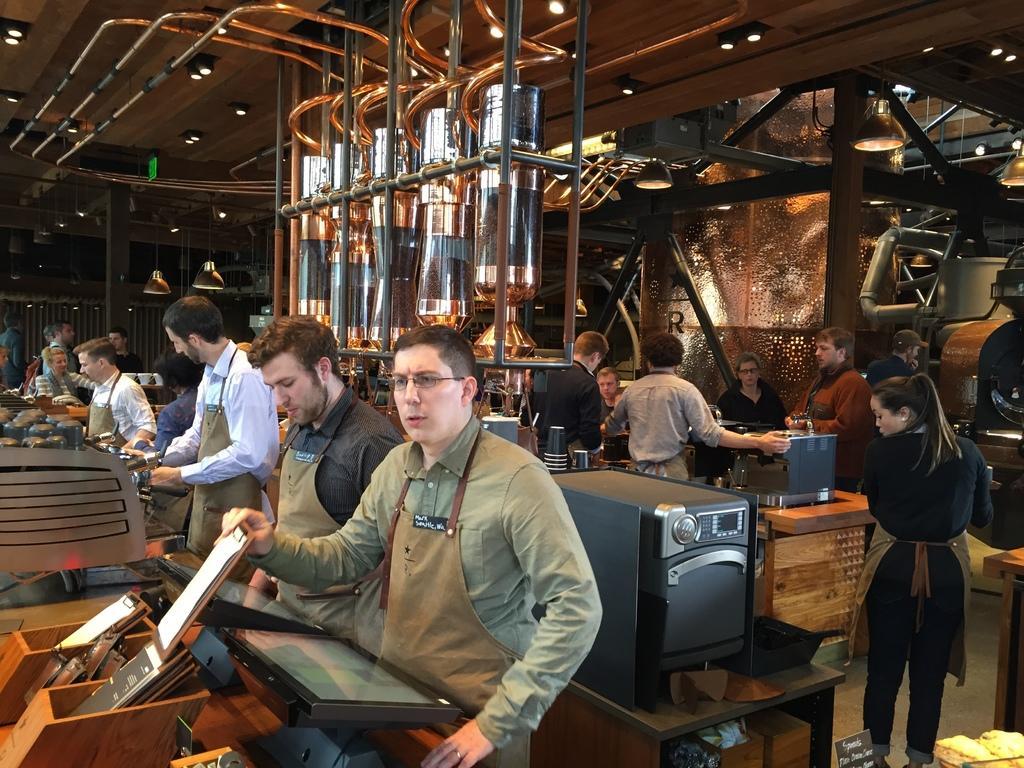In one or two sentences, can you explain what this image depicts? In the center of the image we can see a few people are standing and few people are holding some objects. Around them, we can see tables. On the tables, we can see, baskets, monitors, machines, glasses, bottles, planks, papers and a few other objects. In the bottom right side,we can see some packets. In the background we can see lights, poles, pipes, banners, one machine and a few other objects. 